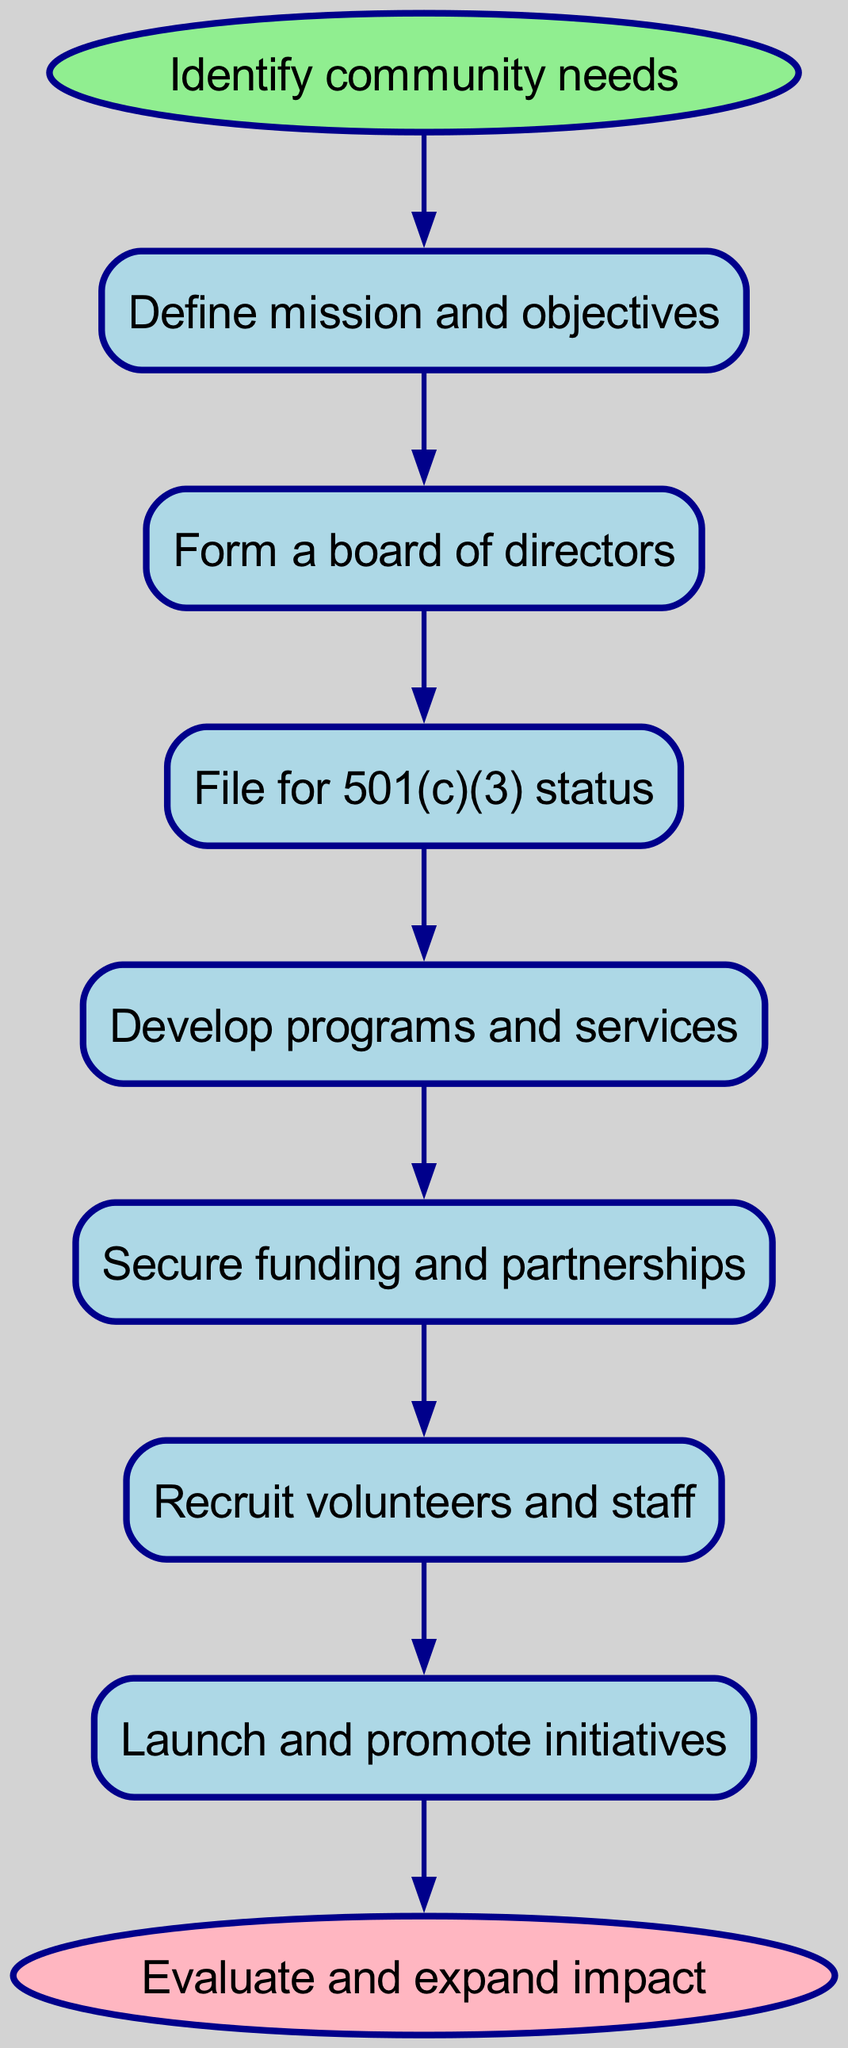What is the first step in the process? The first step in the flow chart is to "Identify community needs," which is indicated as the starting point that leads to defining the mission and objectives.
Answer: Identify community needs How many nodes are present in the diagram? By counting each step from the start to the end and including both the start and end nodes, there are a total of eight nodes in the flow chart.
Answer: Eight What follows after forming a board of directors? According to the flow of the diagram, after forming a board of directors, the next step is to "File for 501(c)(3) status."
Answer: File for 501(c)(3) status What action must be taken before launching initiatives? The flow chart indicates that before launching and promoting initiatives, one must "Recruit volunteers and staff," as this step precedes the launch.
Answer: Recruit volunteers and staff What is the final step in the procedure? The last step in the flow chart leading to the conclusion of the process is "Evaluate and expand impact," indicating that assessment and growth are integral to the nonprofit's mission.
Answer: Evaluate and expand impact Which element comes directly after securing funding and partnerships? The flow from the diagram shows that "Recruit volunteers and staff" comes directly after securing funding and partnerships, creating a sequence in the setup process.
Answer: Recruit volunteers and staff How many connections are there from start to end? The flow chart exhibits a total of seven connections that link each step starting from "Identify community needs" to the final outcome, "Evaluate and expand impact."
Answer: Seven What is the purpose of defining mission and objectives? Defining the mission and objectives serves as the foundational step that guides all subsequent actions and decisions for the nonprofit organization, establishing its purpose.
Answer: Establish its purpose What comes before developing programs and services? As per the sequence in the flow chart, "File for 501(c)(3) status" precedes the step of developing programs and services, indicating the need for legal status before action.
Answer: File for 501(c)(3) status 